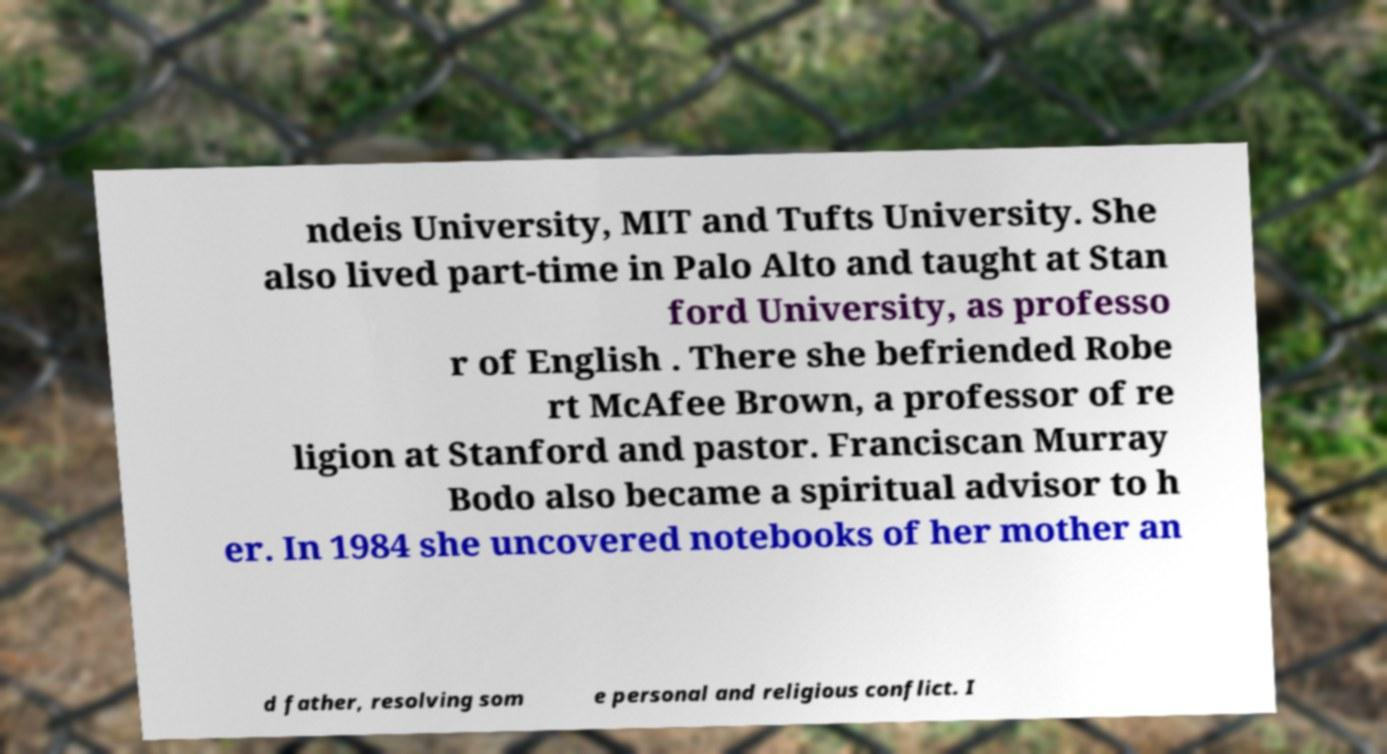What messages or text are displayed in this image? I need them in a readable, typed format. ndeis University, MIT and Tufts University. She also lived part-time in Palo Alto and taught at Stan ford University, as professo r of English . There she befriended Robe rt McAfee Brown, a professor of re ligion at Stanford and pastor. Franciscan Murray Bodo also became a spiritual advisor to h er. In 1984 she uncovered notebooks of her mother an d father, resolving som e personal and religious conflict. I 